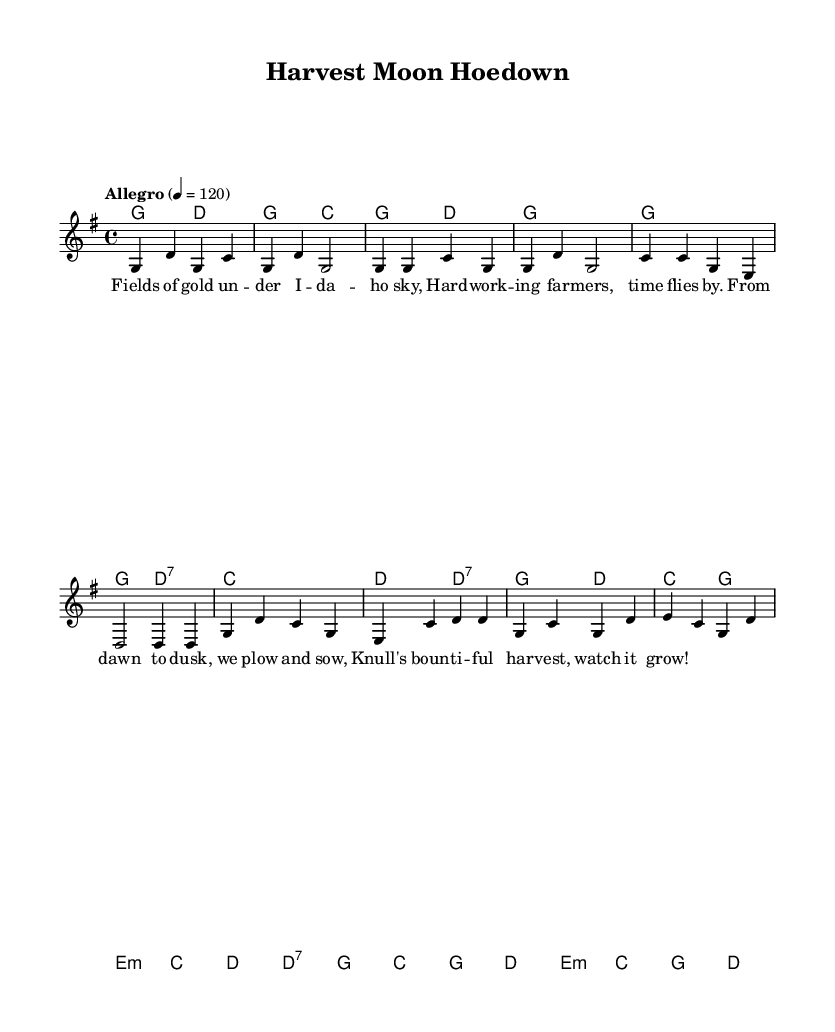What is the key signature of this music? The key signature is G major, which has one sharp (F#). You can determine this from the global section of the sheet music where it states "\key g \major".
Answer: G major What is the time signature of this music? The time signature is 4/4, meaning there are four beats in each measure and the quarter note gets one beat. This is indicated in the global section with "\time 4/4".
Answer: 4/4 What is the tempo marking for this piece? The tempo marking indicates "Allegro," which suggests a lively tempo. The specific speed is set to 120 beats per minute, shown as "4 = 120".
Answer: Allegro What are the first two words of the lyrics? The first two words can be found in the verseWords section of the lyrics. They are the first two syllables when sung. The lyrics begin with "Fields of...".
Answer: Fields of What chord is played in the first measure? The first measure contains the chord G major. You can find it in the harmonies section, where it lists "g2". This indicates a G major chord played for two beats.
Answer: G major How many measures are there in the chorus section? The chorus section is identified by its distinct melody and harmonies, which can be counted in the melody and harmonies notations. In this case, it contains four measures.
Answer: 4 What instruments are likely involved in this piece given the style? This piece fits the Bluegrass genre, which often includes instruments such as the banjo, fiddle, and acoustic guitar. The genre's characteristics influence the instrumentation used.
Answer: Banjo, fiddle, guitar 